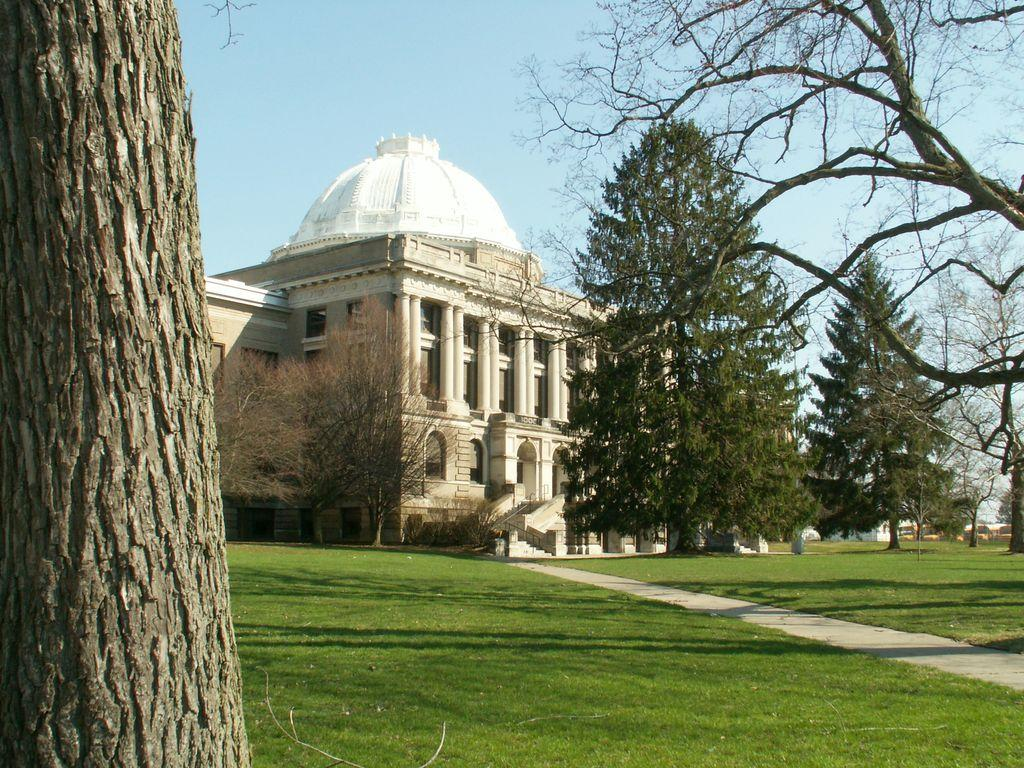What type of area is depicted in the image? There is a garden in the image. What feature can be found within the garden? There is a path in the garden. What can be seen in the distance in the image? There is a palace in the background of the image. What type of vegetation is visible in the background of the image? There are trees in the background of the image. What part of the natural environment is visible in the image? The sky is visible in the background of the image. What type of chalk is being used to draw on the path in the image? There is no chalk present in the image, and therefore no such activity can be observed. 